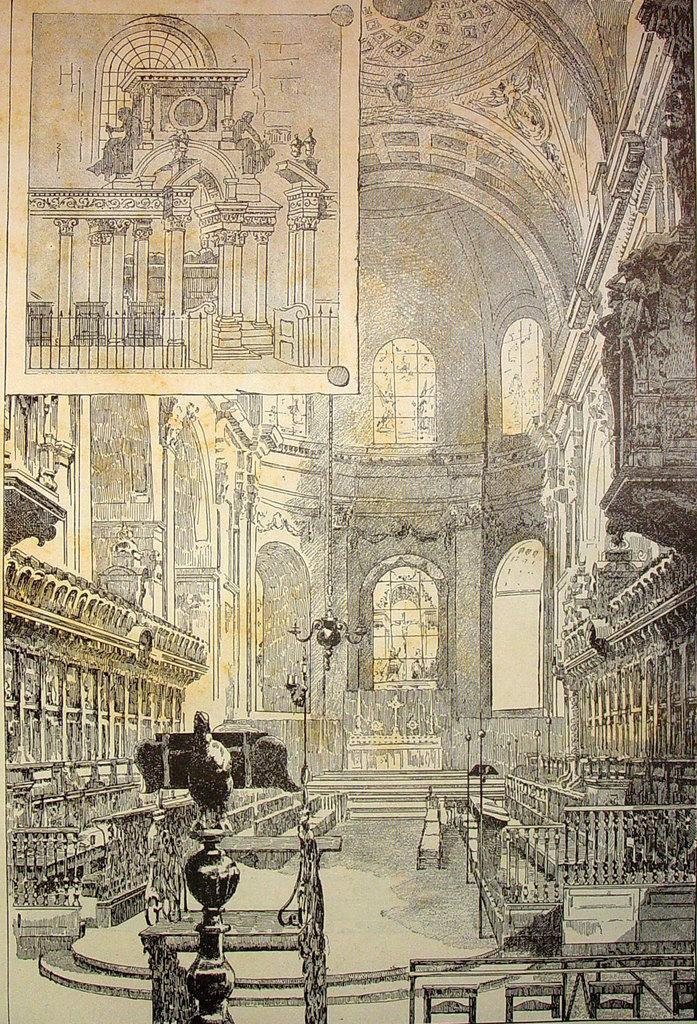What is the main subject of the image? The main subject of the image is a palace. How is the palace depicted in the image? The palace is depicted as a drawing with many pillars and other constructions. Can you describe the second image? The second image provides a clear view of the inside of the palace. What type of mountain can be seen in the background of the palace drawing? There is no mountain visible in the background of the palace drawing; it is a drawing of a palace with no reference to a mountain. 